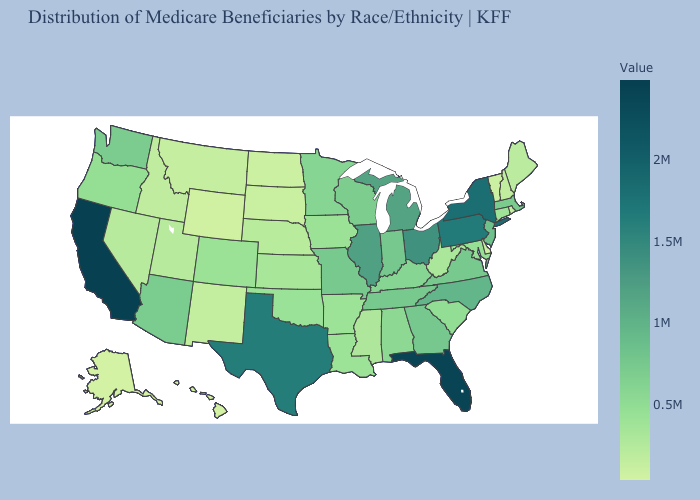Does Wyoming have the highest value in the USA?
Short answer required. No. Does Alaska have the lowest value in the West?
Short answer required. Yes. Among the states that border Delaware , does Maryland have the highest value?
Concise answer only. No. Which states hav the highest value in the MidWest?
Quick response, please. Ohio. Among the states that border New Hampshire , does Vermont have the highest value?
Give a very brief answer. No. 